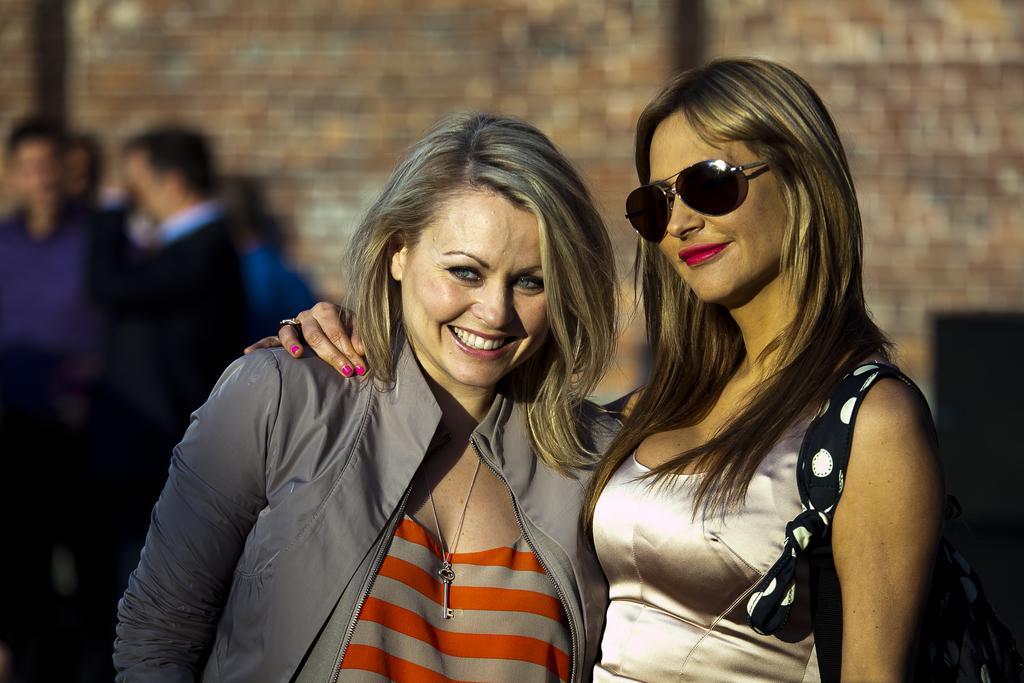Describe this image in one or two sentences. In this image, there are a few people. Among them, we can see a person wearing spectacles. We can also see the blurred background. 